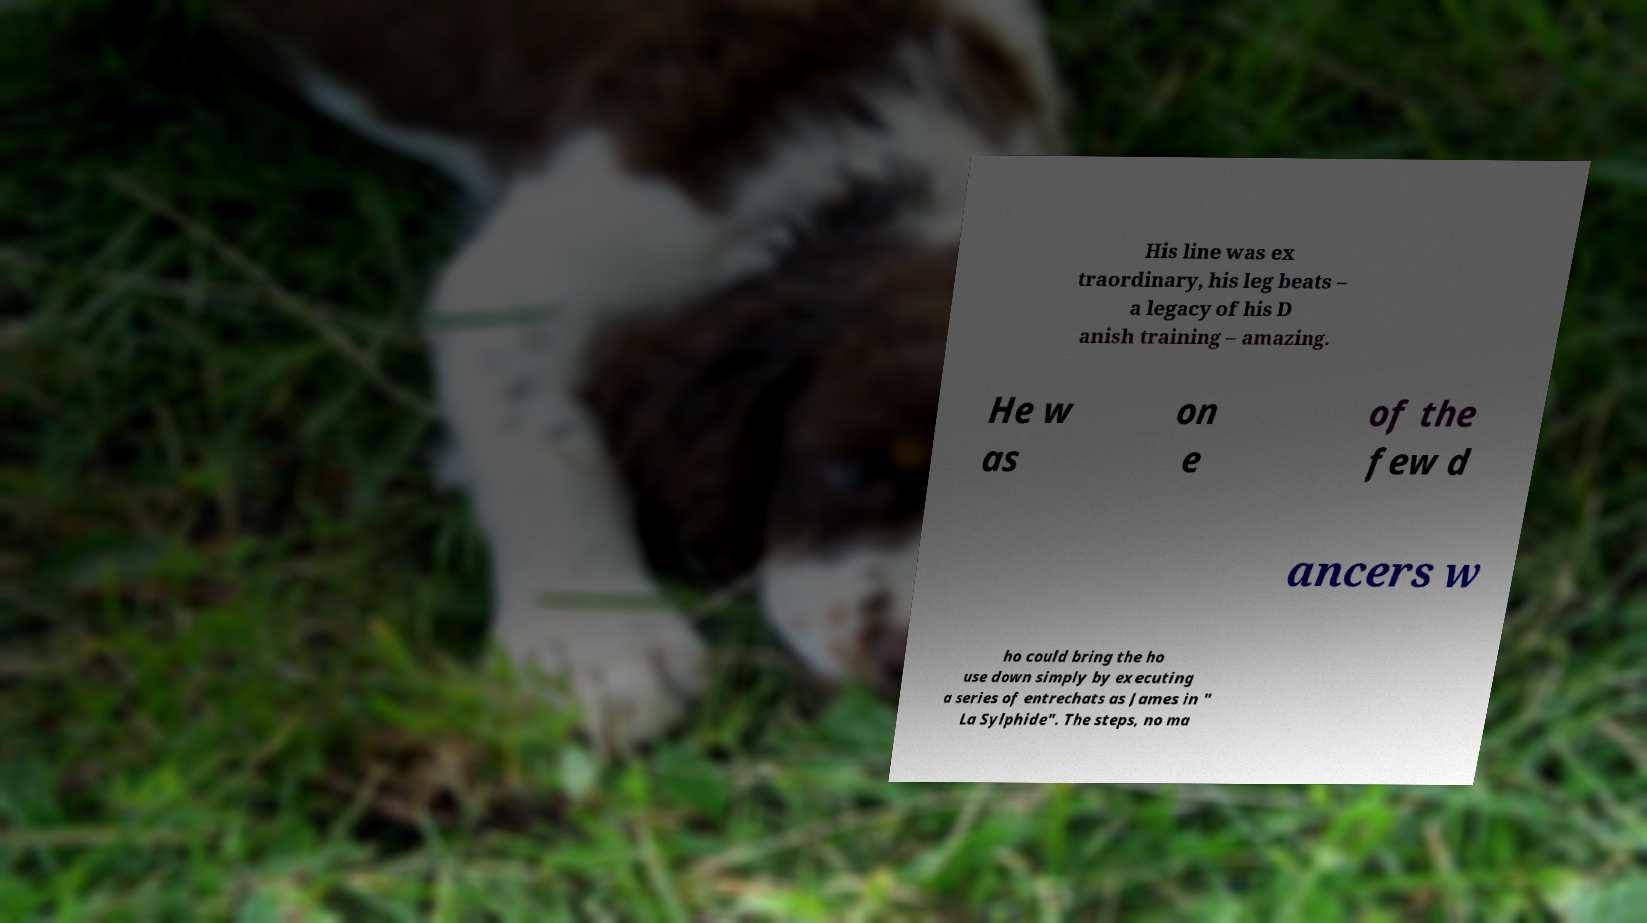For documentation purposes, I need the text within this image transcribed. Could you provide that? His line was ex traordinary, his leg beats – a legacy of his D anish training – amazing. He w as on e of the few d ancers w ho could bring the ho use down simply by executing a series of entrechats as James in " La Sylphide". The steps, no ma 